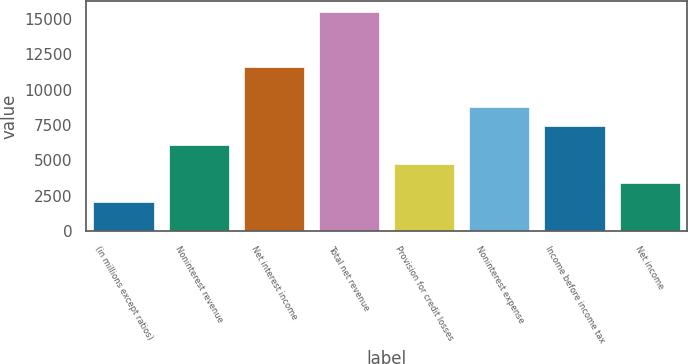Convert chart. <chart><loc_0><loc_0><loc_500><loc_500><bar_chart><fcel>(in millions except ratios)<fcel>Noninterest revenue<fcel>Net interest income<fcel>Total net revenue<fcel>Provision for credit losses<fcel>Noninterest expense<fcel>Income before income tax<fcel>Net income<nl><fcel>2012<fcel>6057.8<fcel>11611<fcel>15498<fcel>4709.2<fcel>8755<fcel>7406.4<fcel>3360.6<nl></chart> 